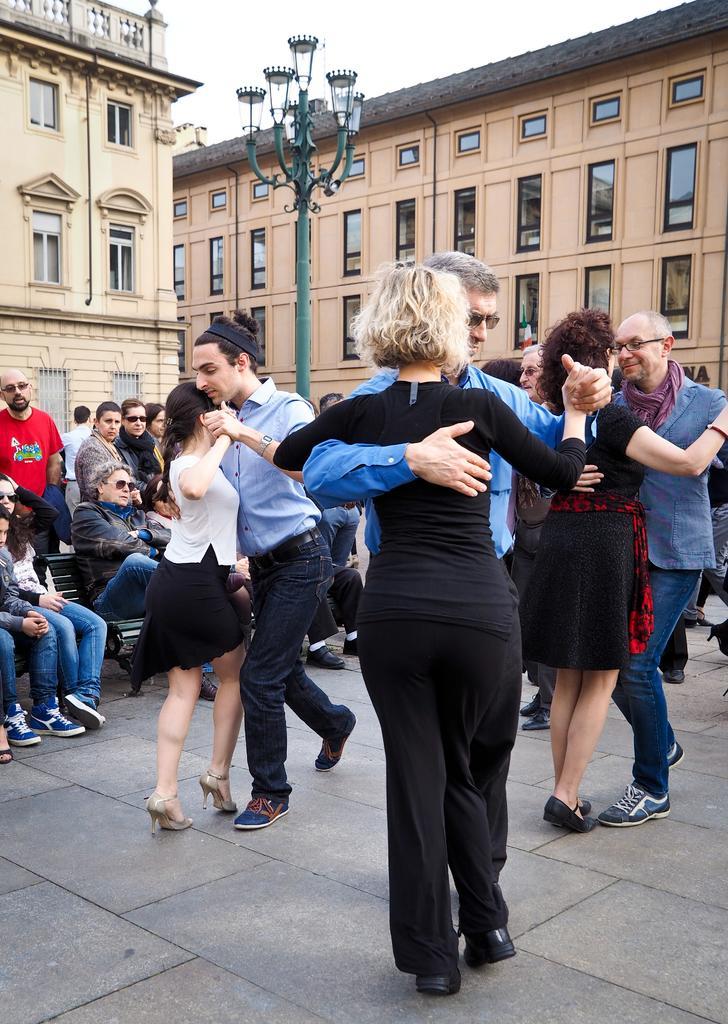Describe this image in one or two sentences. In the image there are few couples dancing on the floor and behind there are few people standing and sitting looking at the performance, in the back there are buildings with many windows all over it, in the middle there is a street light and above there is sky. 